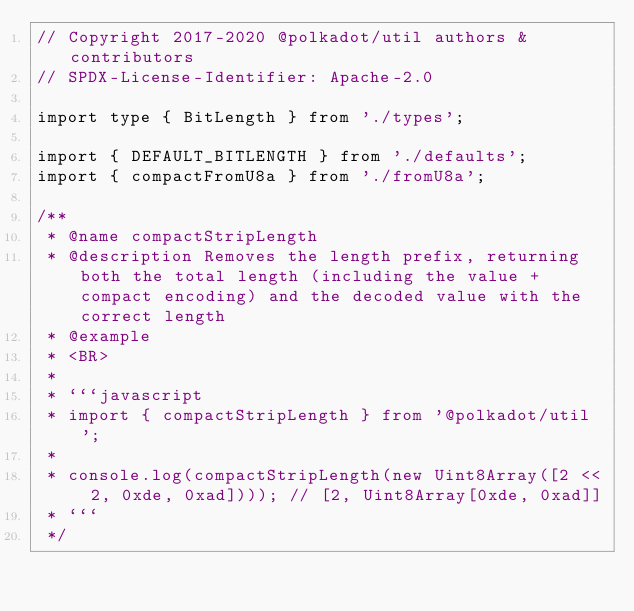<code> <loc_0><loc_0><loc_500><loc_500><_TypeScript_>// Copyright 2017-2020 @polkadot/util authors & contributors
// SPDX-License-Identifier: Apache-2.0

import type { BitLength } from './types';

import { DEFAULT_BITLENGTH } from './defaults';
import { compactFromU8a } from './fromU8a';

/**
 * @name compactStripLength
 * @description Removes the length prefix, returning both the total length (including the value + compact encoding) and the decoded value with the correct length
 * @example
 * <BR>
 *
 * ```javascript
 * import { compactStripLength } from '@polkadot/util';
 *
 * console.log(compactStripLength(new Uint8Array([2 << 2, 0xde, 0xad]))); // [2, Uint8Array[0xde, 0xad]]
 * ```
 */</code> 